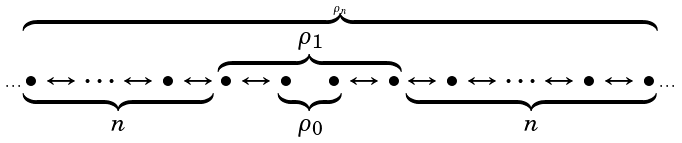<formula> <loc_0><loc_0><loc_500><loc_500>\cdots \overbrace { \underbrace { \bullet \leftrightarrow \cdots \leftrightarrow \bullet \leftrightarrow } _ { n } \overbrace { \bullet \leftrightarrow \underbrace { \bullet \quad \bullet } _ { \rho _ { 0 } } \leftrightarrow \bullet } ^ { \rho _ { 1 } } \underbrace { \leftrightarrow \bullet \leftrightarrow \cdots \leftrightarrow \bullet \leftrightarrow \bullet } _ { n } } ^ { \rho _ { n } } \cdots</formula> 